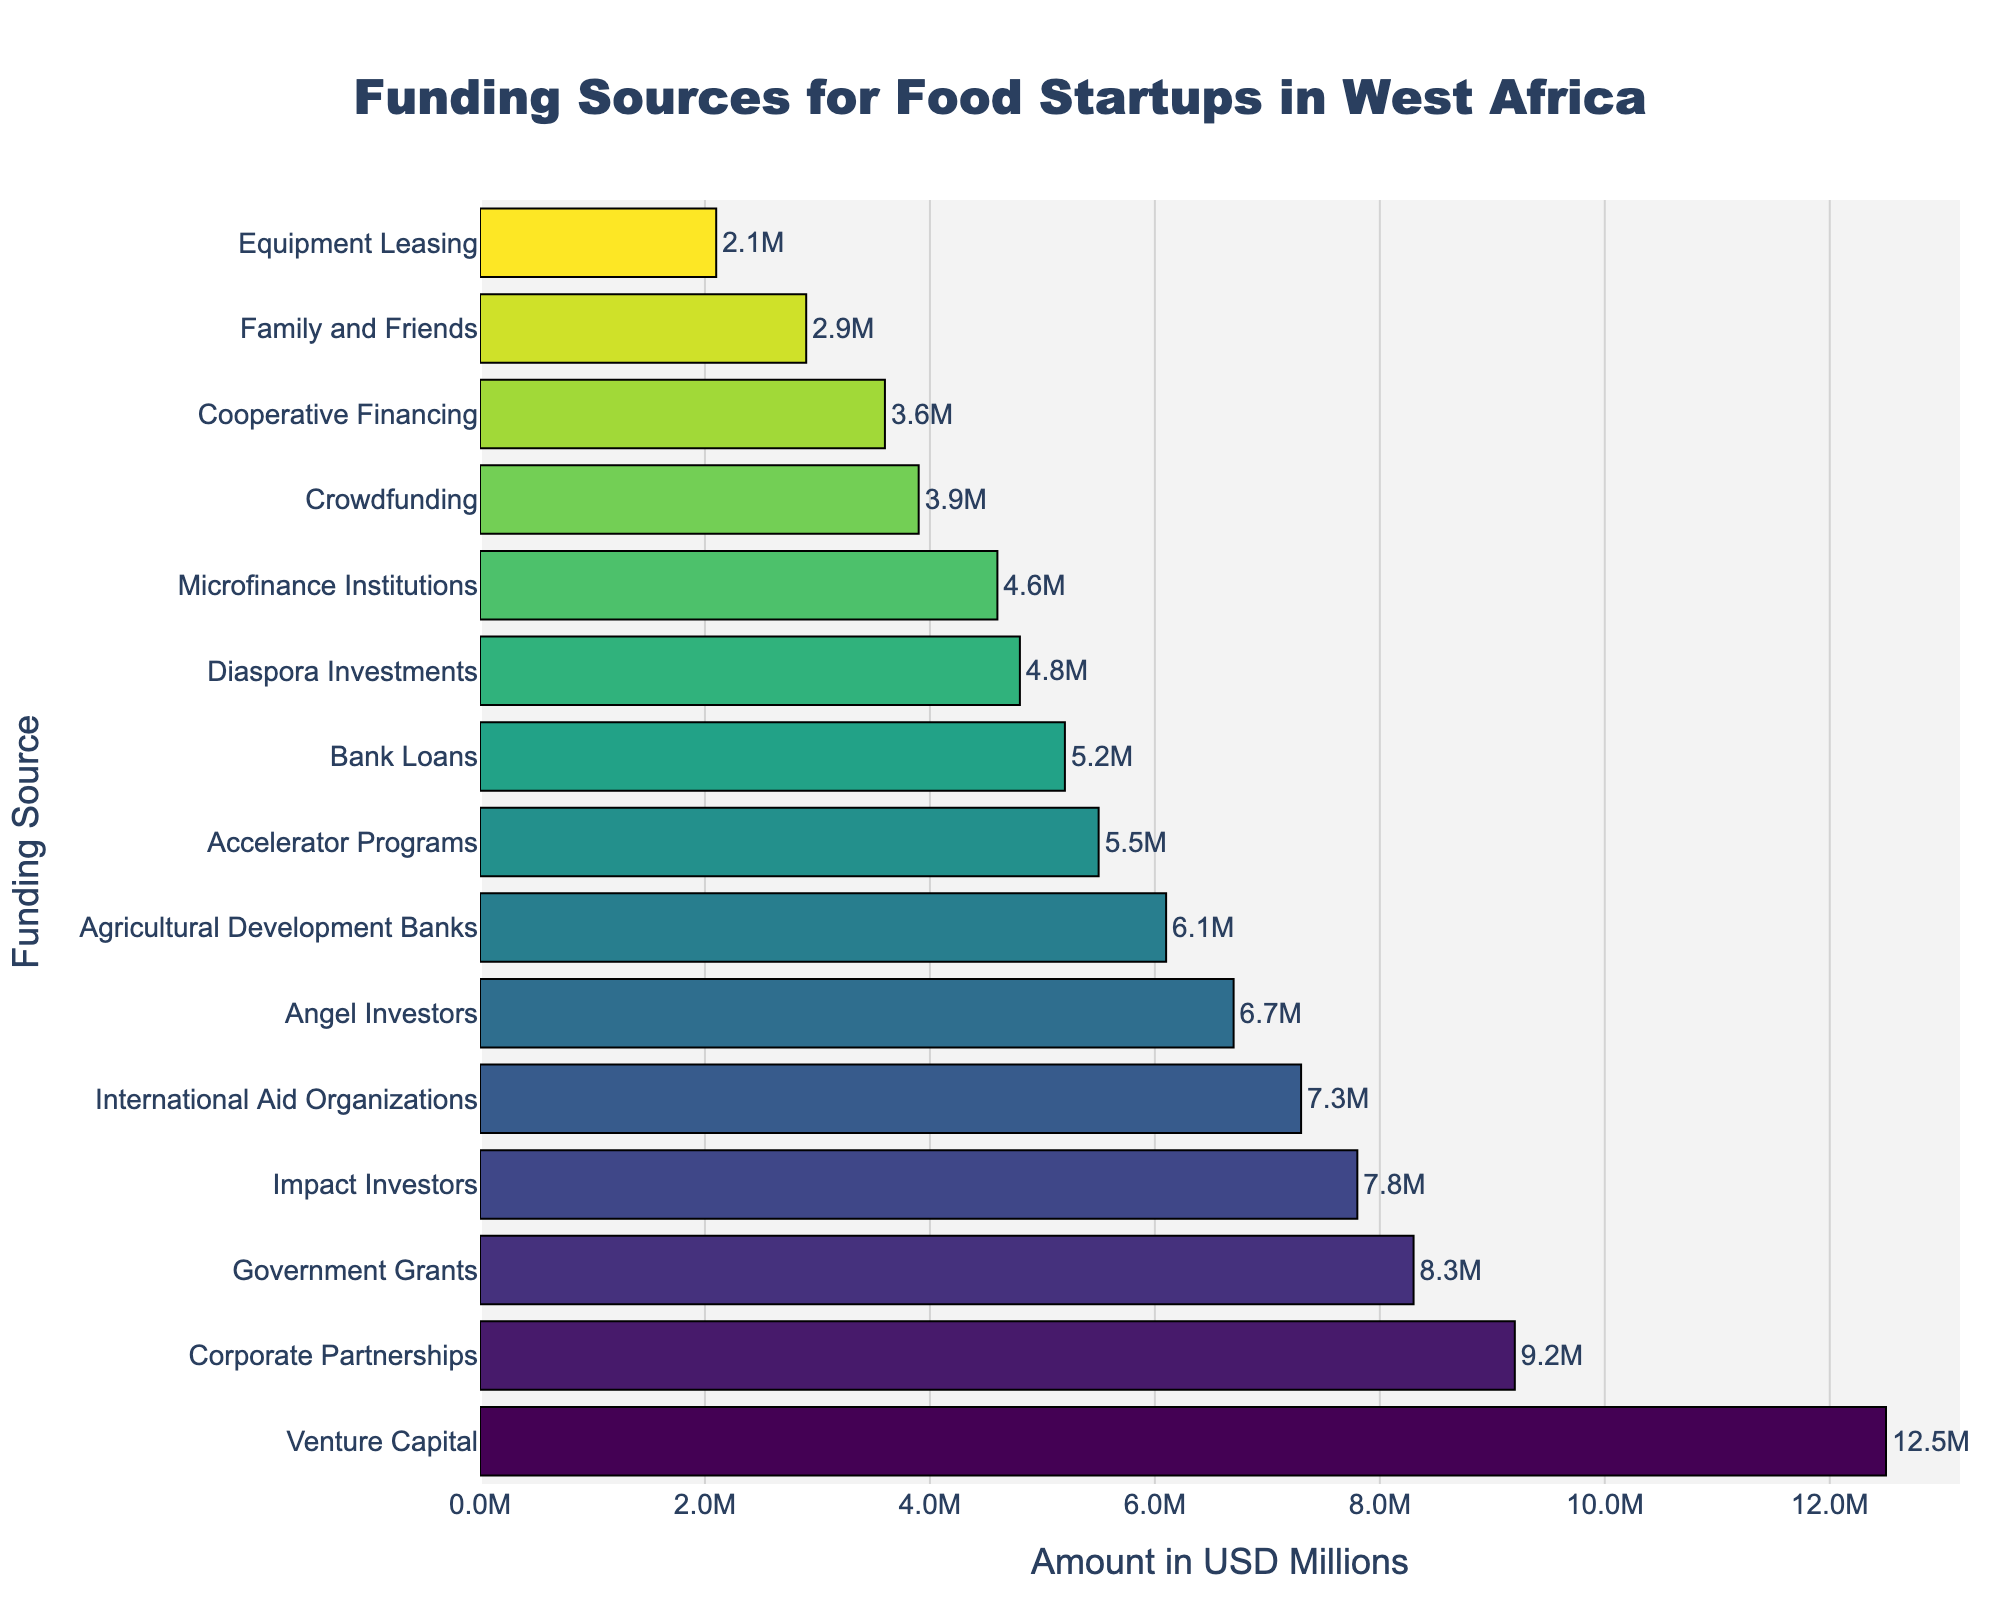What's the largest funding source for food startups in West Africa? The largest funding source is the one with the greatest amount in USD Millions. Looking at the bar chart, 'Venture Capital' has the longest bar.
Answer: Venture Capital What's the total amount of funding sourced from Angel Investors and Government Grants? To find the total amount of funding from Angel Investors and Government Grants, add the amounts for 'Angel Investors' (6.7M) and 'Government Grants' (8.3M). 6.7 + 8.3 = 15.
Answer: 15 How much more funding does Venture Capital provide compared to Crowdfunding? The amount from Venture Capital is 12.5M and from Crowdfunding is 3.9M. The difference is calculated as 12.5 - 3.9 = 8.6.
Answer: 8.6 Which funding source provides the least amount of funding? The smallest funding source is the one with the shortest bar. 'Equipment Leasing' has the shortest bar in the chart.
Answer: Equipment Leasing What's the average funding amount across all sources? To find the average, sum all the amounts and divide by the number of sources. The total is 12.5 + 8.3 + 6.7 + 5.2 + 3.9 + 7.8 + 4.6 + 6.1 + 9.2 + 5.5 + 4.8 + 7.3 + 2.9 + 3.6 + 2.1 = 90.5. There are 15 sources, so the average is 90.5 / 15 = 6.03.
Answer: 6.03 Between Corporate Partnerships and Impact Investors, which funding source provides more and by how much? Corporate Partnerships provide 9.2M and Impact Investors provide 7.8M. The difference is 9.2 - 7.8 = 1.4.
Answer: Corporate Partnerships, 1.4 Which three funding sources collectively provide more than 25 million USD in total? Adding the amounts of the top three sources: Venture Capital (12.5M), Corporate Partnerships (9.2M), Government Grants (8.3M) results in a sum of 12.5 + 9.2 + 8.3 = 30, which is more than 25.
Answer: Venture Capital, Corporate Partnerships, Government Grants What is the combined funding amount from Accelerator Programs, Diaspora Investments, and Bank Loans? To find the combined amount, add the figures: Accelerator Programs (5.5M), Diaspora Investments (4.8M), and Bank Loans (5.2M). 5.5 + 4.8 + 5.2 = 15.5.
Answer: 15.5 